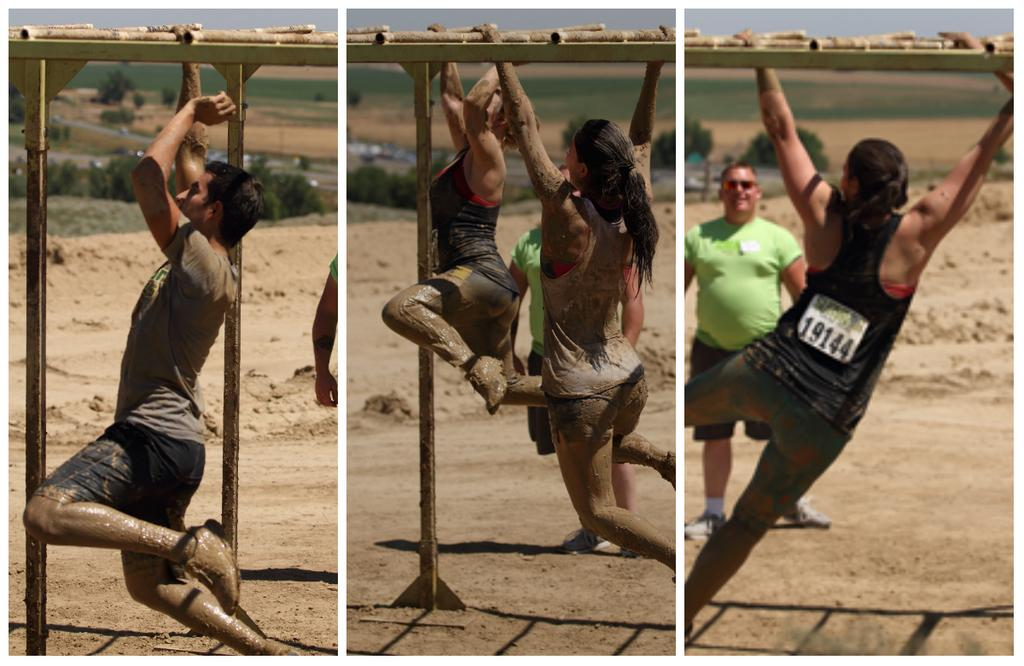What type of image is in the picture? There is a collage image in the picture. What are the people in the image doing? A: People are hanging onto a metal rod in the image. What natural elements can be seen in the image? Trees and sand are visible in the image. What is the person standing on in the image? There is a person standing on a surface in the image. How many letters can be seen in the image? There are no letters visible in the image. What type of bee can be seen buzzing around the trees in the image? There are no bees present in the image; only trees and sand are visible. 